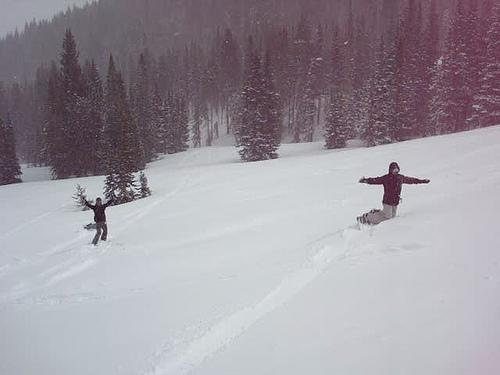Identify the main color of the sky in the picture. The sky is blueish grey. What kind of sport is the person in the picture performing? The person is snowboarding. What's the predominant weather condition in the image? The predominant weather condition is snowfall. In a poetic manner, describe what the person in the hooded coat is doing. Amidst the snow, a soul in a hooded coat kneels, embracing the frosted air with arms outstretched wide. What type of trees are mostly visible in the image? Pine trees are mainly visible in the image. Describe the type of jacket the person is wearing. The person is wearing a black hooded jacket. Mention the state of the ground in the image. Most of the ground is covered with a blanket of white snow. Explain the environment in a single sentence. A snow-covered landscape with trees, a skier, and a track in the ground sets a tranquil winter scene. Count the number of trees with snow on them. There are at least 5 trees with snow on their branches. Describe the pants worn by the person kneeling. The person is wearing light tan or khaki-colored ski pants. 